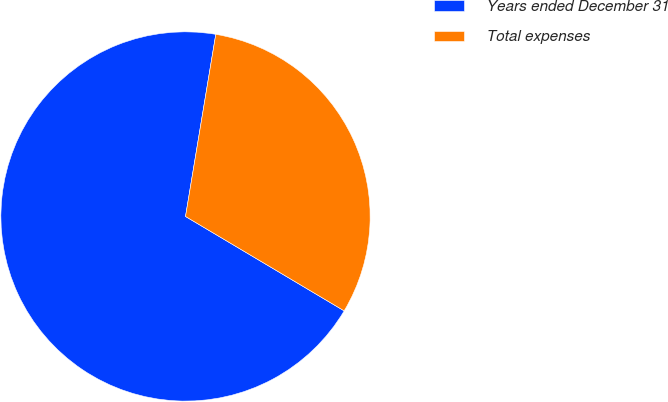Convert chart. <chart><loc_0><loc_0><loc_500><loc_500><pie_chart><fcel>Years ended December 31<fcel>Total expenses<nl><fcel>69.08%<fcel>30.92%<nl></chart> 